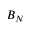Convert formula to latex. <formula><loc_0><loc_0><loc_500><loc_500>B _ { N }</formula> 